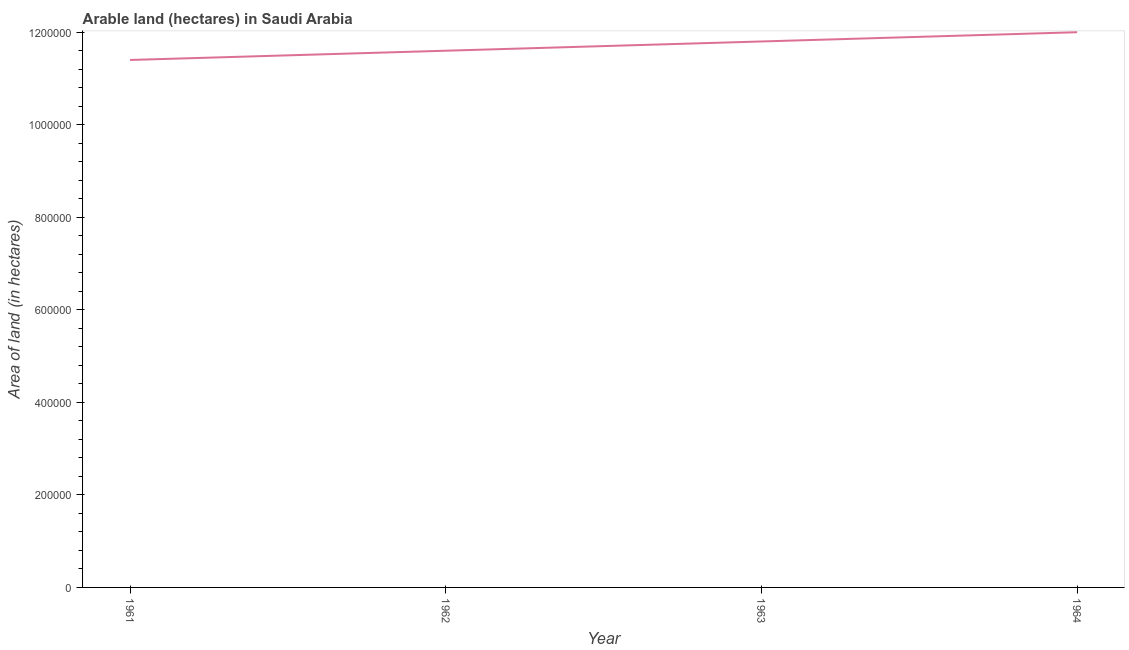What is the area of land in 1963?
Provide a short and direct response. 1.18e+06. Across all years, what is the maximum area of land?
Provide a succinct answer. 1.20e+06. Across all years, what is the minimum area of land?
Offer a terse response. 1.14e+06. In which year was the area of land maximum?
Keep it short and to the point. 1964. What is the sum of the area of land?
Offer a very short reply. 4.68e+06. What is the difference between the area of land in 1962 and 1964?
Keep it short and to the point. -4.00e+04. What is the average area of land per year?
Your response must be concise. 1.17e+06. What is the median area of land?
Ensure brevity in your answer.  1.17e+06. In how many years, is the area of land greater than 880000 hectares?
Your answer should be very brief. 4. What is the ratio of the area of land in 1961 to that in 1964?
Give a very brief answer. 0.95. Is the difference between the area of land in 1963 and 1964 greater than the difference between any two years?
Offer a very short reply. No. Is the sum of the area of land in 1962 and 1963 greater than the maximum area of land across all years?
Make the answer very short. Yes. What is the difference between the highest and the lowest area of land?
Your response must be concise. 6.00e+04. Does the area of land monotonically increase over the years?
Your answer should be very brief. Yes. What is the title of the graph?
Ensure brevity in your answer.  Arable land (hectares) in Saudi Arabia. What is the label or title of the X-axis?
Provide a succinct answer. Year. What is the label or title of the Y-axis?
Your response must be concise. Area of land (in hectares). What is the Area of land (in hectares) in 1961?
Make the answer very short. 1.14e+06. What is the Area of land (in hectares) in 1962?
Provide a succinct answer. 1.16e+06. What is the Area of land (in hectares) of 1963?
Keep it short and to the point. 1.18e+06. What is the Area of land (in hectares) in 1964?
Your answer should be compact. 1.20e+06. What is the difference between the Area of land (in hectares) in 1961 and 1964?
Offer a terse response. -6.00e+04. What is the difference between the Area of land (in hectares) in 1962 and 1964?
Give a very brief answer. -4.00e+04. What is the difference between the Area of land (in hectares) in 1963 and 1964?
Your answer should be very brief. -2.00e+04. What is the ratio of the Area of land (in hectares) in 1961 to that in 1964?
Provide a short and direct response. 0.95. What is the ratio of the Area of land (in hectares) in 1962 to that in 1964?
Provide a short and direct response. 0.97. 